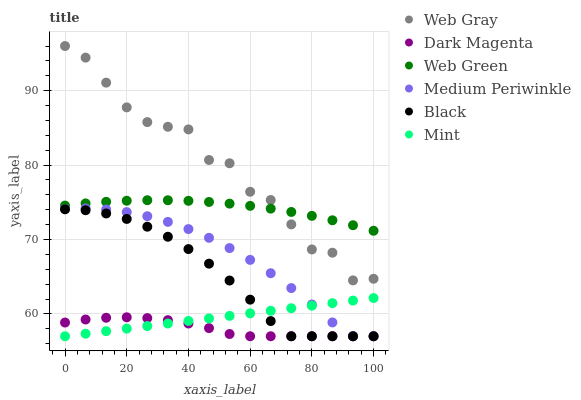Does Dark Magenta have the minimum area under the curve?
Answer yes or no. Yes. Does Web Gray have the maximum area under the curve?
Answer yes or no. Yes. Does Medium Periwinkle have the minimum area under the curve?
Answer yes or no. No. Does Medium Periwinkle have the maximum area under the curve?
Answer yes or no. No. Is Mint the smoothest?
Answer yes or no. Yes. Is Web Gray the roughest?
Answer yes or no. Yes. Is Dark Magenta the smoothest?
Answer yes or no. No. Is Dark Magenta the roughest?
Answer yes or no. No. Does Dark Magenta have the lowest value?
Answer yes or no. Yes. Does Web Green have the lowest value?
Answer yes or no. No. Does Web Gray have the highest value?
Answer yes or no. Yes. Does Medium Periwinkle have the highest value?
Answer yes or no. No. Is Medium Periwinkle less than Web Gray?
Answer yes or no. Yes. Is Web Green greater than Medium Periwinkle?
Answer yes or no. Yes. Does Dark Magenta intersect Mint?
Answer yes or no. Yes. Is Dark Magenta less than Mint?
Answer yes or no. No. Is Dark Magenta greater than Mint?
Answer yes or no. No. Does Medium Periwinkle intersect Web Gray?
Answer yes or no. No. 